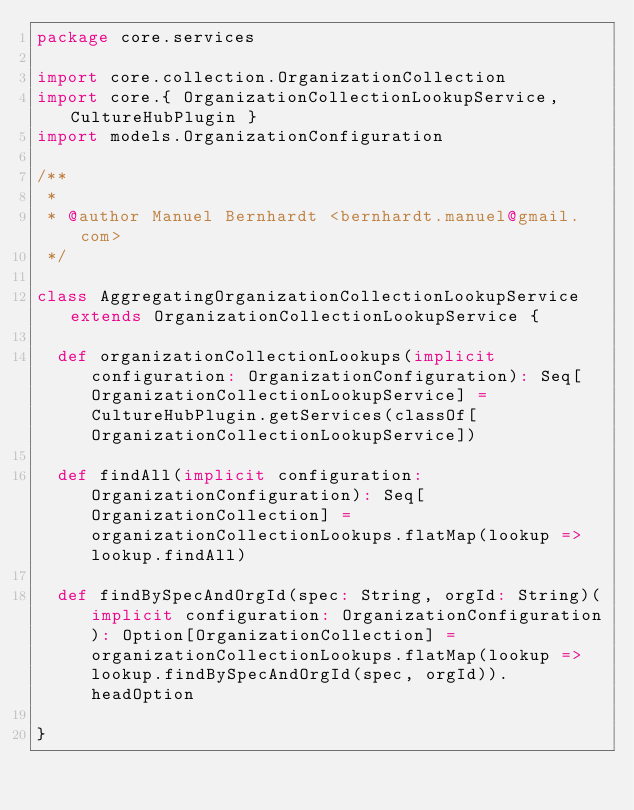Convert code to text. <code><loc_0><loc_0><loc_500><loc_500><_Scala_>package core.services

import core.collection.OrganizationCollection
import core.{ OrganizationCollectionLookupService, CultureHubPlugin }
import models.OrganizationConfiguration

/**
 *
 * @author Manuel Bernhardt <bernhardt.manuel@gmail.com>
 */

class AggregatingOrganizationCollectionLookupService extends OrganizationCollectionLookupService {

  def organizationCollectionLookups(implicit configuration: OrganizationConfiguration): Seq[OrganizationCollectionLookupService] = CultureHubPlugin.getServices(classOf[OrganizationCollectionLookupService])

  def findAll(implicit configuration: OrganizationConfiguration): Seq[OrganizationCollection] = organizationCollectionLookups.flatMap(lookup => lookup.findAll)

  def findBySpecAndOrgId(spec: String, orgId: String)(implicit configuration: OrganizationConfiguration): Option[OrganizationCollection] = organizationCollectionLookups.flatMap(lookup => lookup.findBySpecAndOrgId(spec, orgId)).headOption

}</code> 